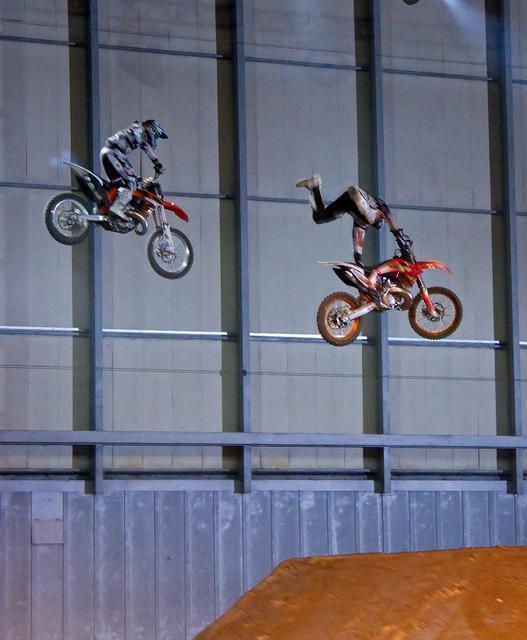How many bikes are there?
Give a very brief answer. 2. How many people are in the photo?
Give a very brief answer. 2. How many motorcycles are there?
Give a very brief answer. 2. 